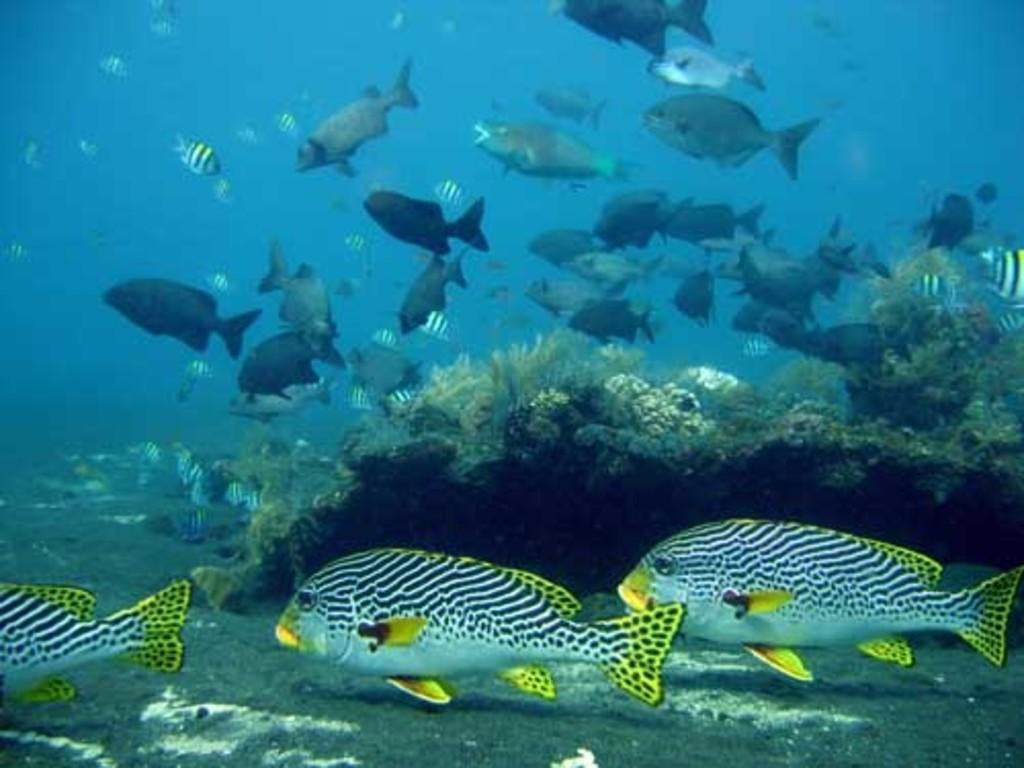What activity are the group of people engaged in? The group of people are having a picnic. What objects are present near the group of people? There is a basket and a blanket next to them. What type of surface are the people sitting on? The people are sitting on the grass. How many ants can be seen carrying drugs on the blanket in the image? There are no ants or drugs present in the image. What is the existence of the group of people in the image trying to prove? The image does not depict any philosophical or existential concepts, so it cannot be used to prove any particular existence. 